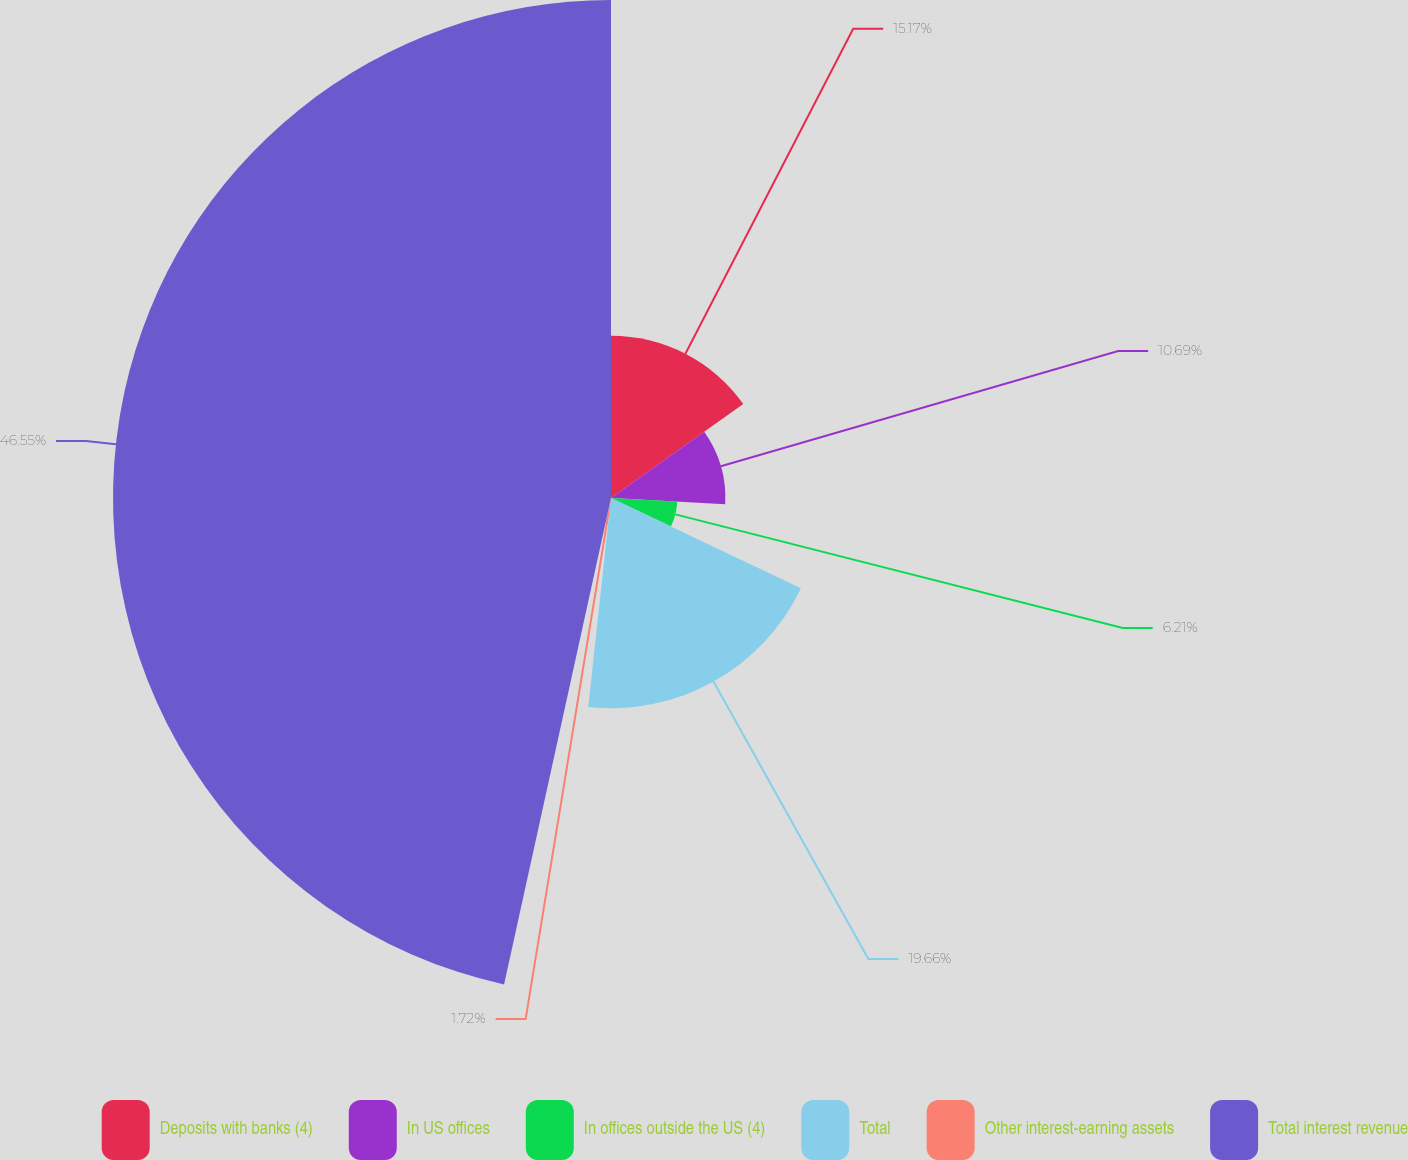Convert chart to OTSL. <chart><loc_0><loc_0><loc_500><loc_500><pie_chart><fcel>Deposits with banks (4)<fcel>In US offices<fcel>In offices outside the US (4)<fcel>Total<fcel>Other interest-earning assets<fcel>Total interest revenue<nl><fcel>15.17%<fcel>10.69%<fcel>6.21%<fcel>19.66%<fcel>1.72%<fcel>46.56%<nl></chart> 